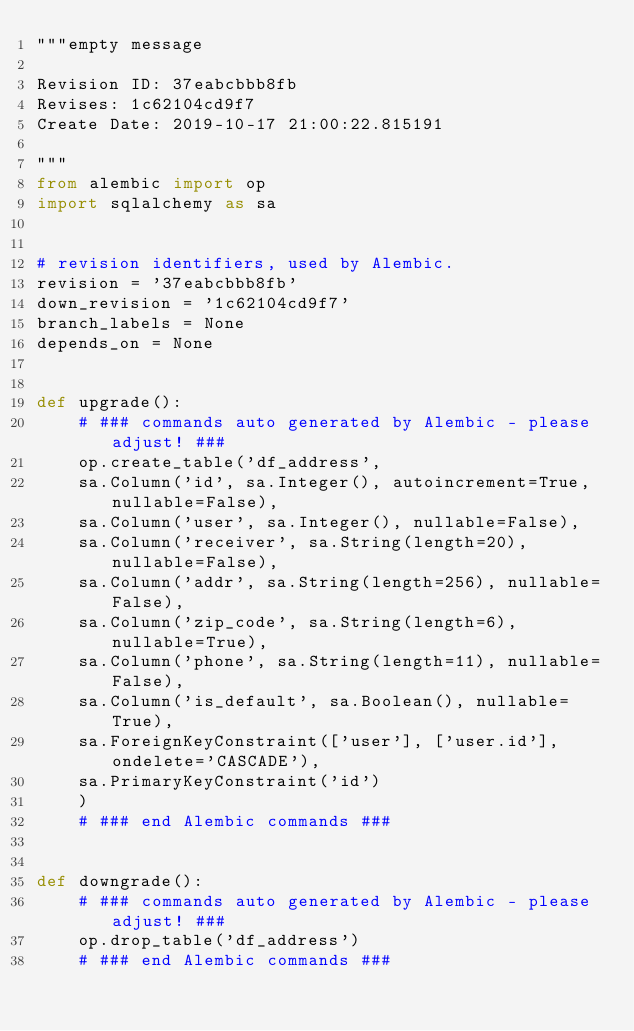<code> <loc_0><loc_0><loc_500><loc_500><_Python_>"""empty message

Revision ID: 37eabcbbb8fb
Revises: 1c62104cd9f7
Create Date: 2019-10-17 21:00:22.815191

"""
from alembic import op
import sqlalchemy as sa


# revision identifiers, used by Alembic.
revision = '37eabcbbb8fb'
down_revision = '1c62104cd9f7'
branch_labels = None
depends_on = None


def upgrade():
    # ### commands auto generated by Alembic - please adjust! ###
    op.create_table('df_address',
    sa.Column('id', sa.Integer(), autoincrement=True, nullable=False),
    sa.Column('user', sa.Integer(), nullable=False),
    sa.Column('receiver', sa.String(length=20), nullable=False),
    sa.Column('addr', sa.String(length=256), nullable=False),
    sa.Column('zip_code', sa.String(length=6), nullable=True),
    sa.Column('phone', sa.String(length=11), nullable=False),
    sa.Column('is_default', sa.Boolean(), nullable=True),
    sa.ForeignKeyConstraint(['user'], ['user.id'], ondelete='CASCADE'),
    sa.PrimaryKeyConstraint('id')
    )
    # ### end Alembic commands ###


def downgrade():
    # ### commands auto generated by Alembic - please adjust! ###
    op.drop_table('df_address')
    # ### end Alembic commands ###
</code> 